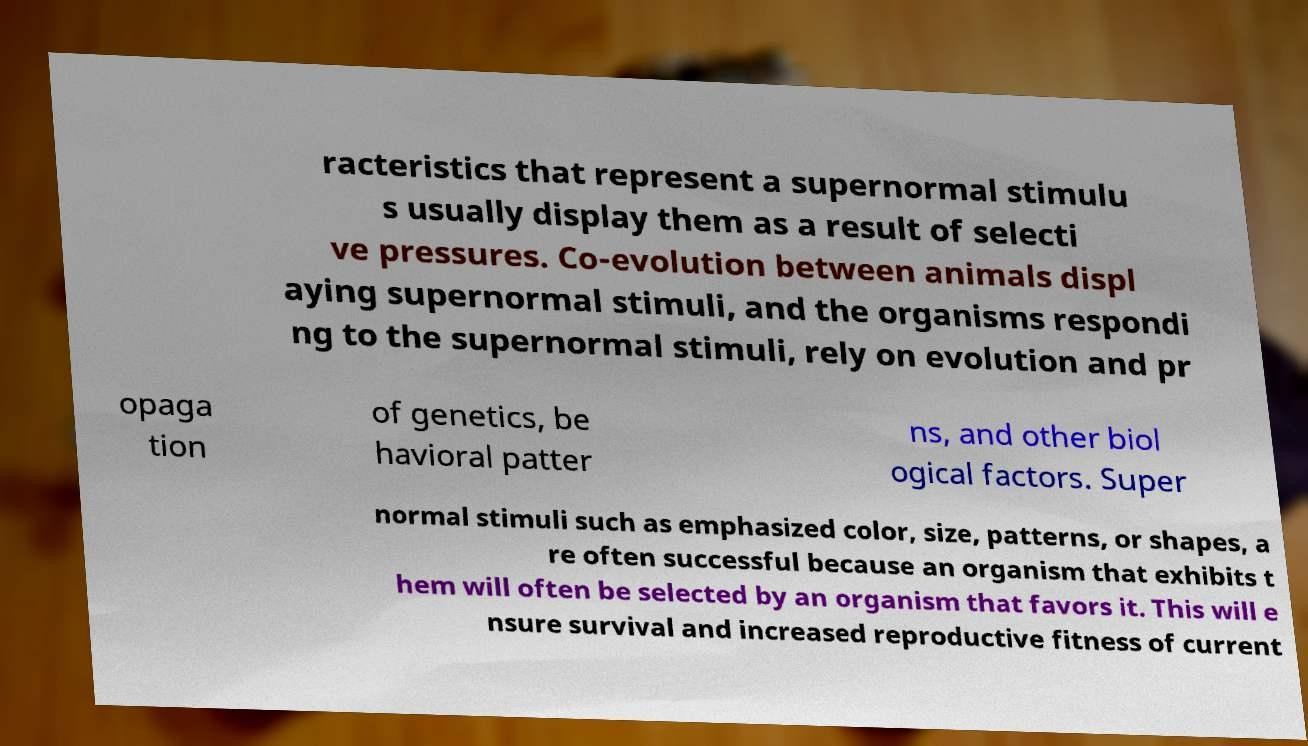Could you extract and type out the text from this image? racteristics that represent a supernormal stimulu s usually display them as a result of selecti ve pressures. Co-evolution between animals displ aying supernormal stimuli, and the organisms respondi ng to the supernormal stimuli, rely on evolution and pr opaga tion of genetics, be havioral patter ns, and other biol ogical factors. Super normal stimuli such as emphasized color, size, patterns, or shapes, a re often successful because an organism that exhibits t hem will often be selected by an organism that favors it. This will e nsure survival and increased reproductive fitness of current 